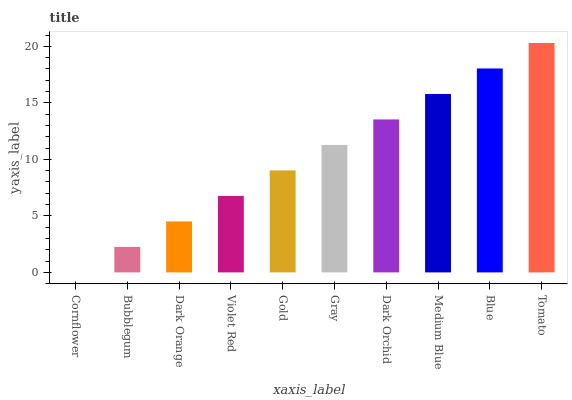Is Cornflower the minimum?
Answer yes or no. Yes. Is Tomato the maximum?
Answer yes or no. Yes. Is Bubblegum the minimum?
Answer yes or no. No. Is Bubblegum the maximum?
Answer yes or no. No. Is Bubblegum greater than Cornflower?
Answer yes or no. Yes. Is Cornflower less than Bubblegum?
Answer yes or no. Yes. Is Cornflower greater than Bubblegum?
Answer yes or no. No. Is Bubblegum less than Cornflower?
Answer yes or no. No. Is Gray the high median?
Answer yes or no. Yes. Is Gold the low median?
Answer yes or no. Yes. Is Tomato the high median?
Answer yes or no. No. Is Tomato the low median?
Answer yes or no. No. 